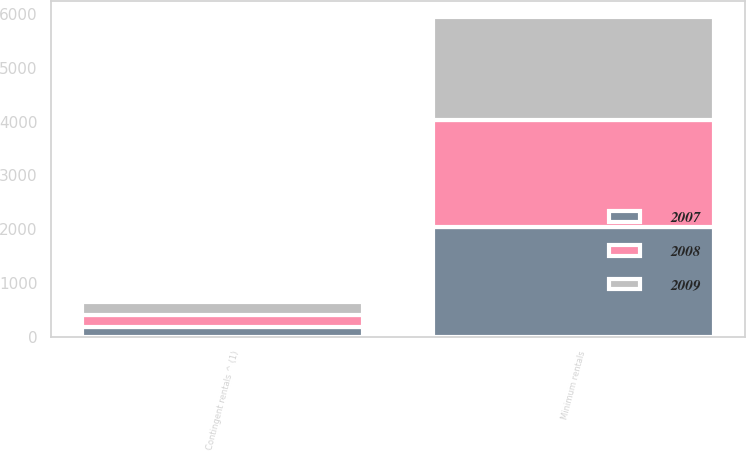Convert chart to OTSL. <chart><loc_0><loc_0><loc_500><loc_500><stacked_bar_chart><ecel><fcel>Minimum rentals<fcel>Contingent rentals ^ (1)<nl><fcel>2007<fcel>2047<fcel>181<nl><fcel>2008<fcel>1990<fcel>228<nl><fcel>2009<fcel>1916<fcel>241<nl></chart> 